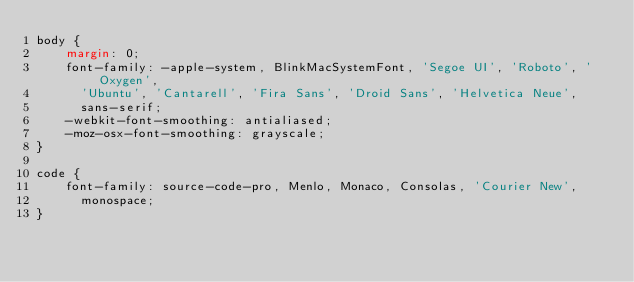<code> <loc_0><loc_0><loc_500><loc_500><_CSS_>body {
    margin: 0;
    font-family: -apple-system, BlinkMacSystemFont, 'Segoe UI', 'Roboto', 'Oxygen',
      'Ubuntu', 'Cantarell', 'Fira Sans', 'Droid Sans', 'Helvetica Neue',
      sans-serif;
    -webkit-font-smoothing: antialiased;
    -moz-osx-font-smoothing: grayscale;
}
  
code {
    font-family: source-code-pro, Menlo, Monaco, Consolas, 'Courier New',
      monospace;
}
  </code> 